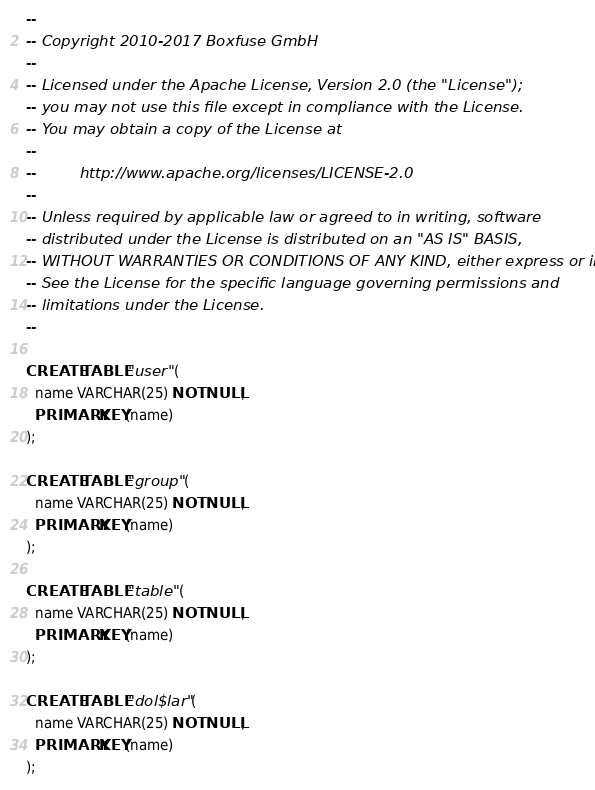Convert code to text. <code><loc_0><loc_0><loc_500><loc_500><_SQL_>--
-- Copyright 2010-2017 Boxfuse GmbH
--
-- Licensed under the Apache License, Version 2.0 (the "License");
-- you may not use this file except in compliance with the License.
-- You may obtain a copy of the License at
--
--         http://www.apache.org/licenses/LICENSE-2.0
--
-- Unless required by applicable law or agreed to in writing, software
-- distributed under the License is distributed on an "AS IS" BASIS,
-- WITHOUT WARRANTIES OR CONDITIONS OF ANY KIND, either express or implied.
-- See the License for the specific language governing permissions and
-- limitations under the License.
--

CREATE TABLE "user" (
  name VARCHAR(25) NOT NULL,
  PRIMARY KEY(name)
);

CREATE TABLE "group" (
  name VARCHAR(25) NOT NULL,
  PRIMARY KEY(name)
);

CREATE TABLE "table" (
  name VARCHAR(25) NOT NULL,
  PRIMARY KEY(name)
);

CREATE TABLE "dol$lar" (
  name VARCHAR(25) NOT NULL,
  PRIMARY KEY(name)
);</code> 